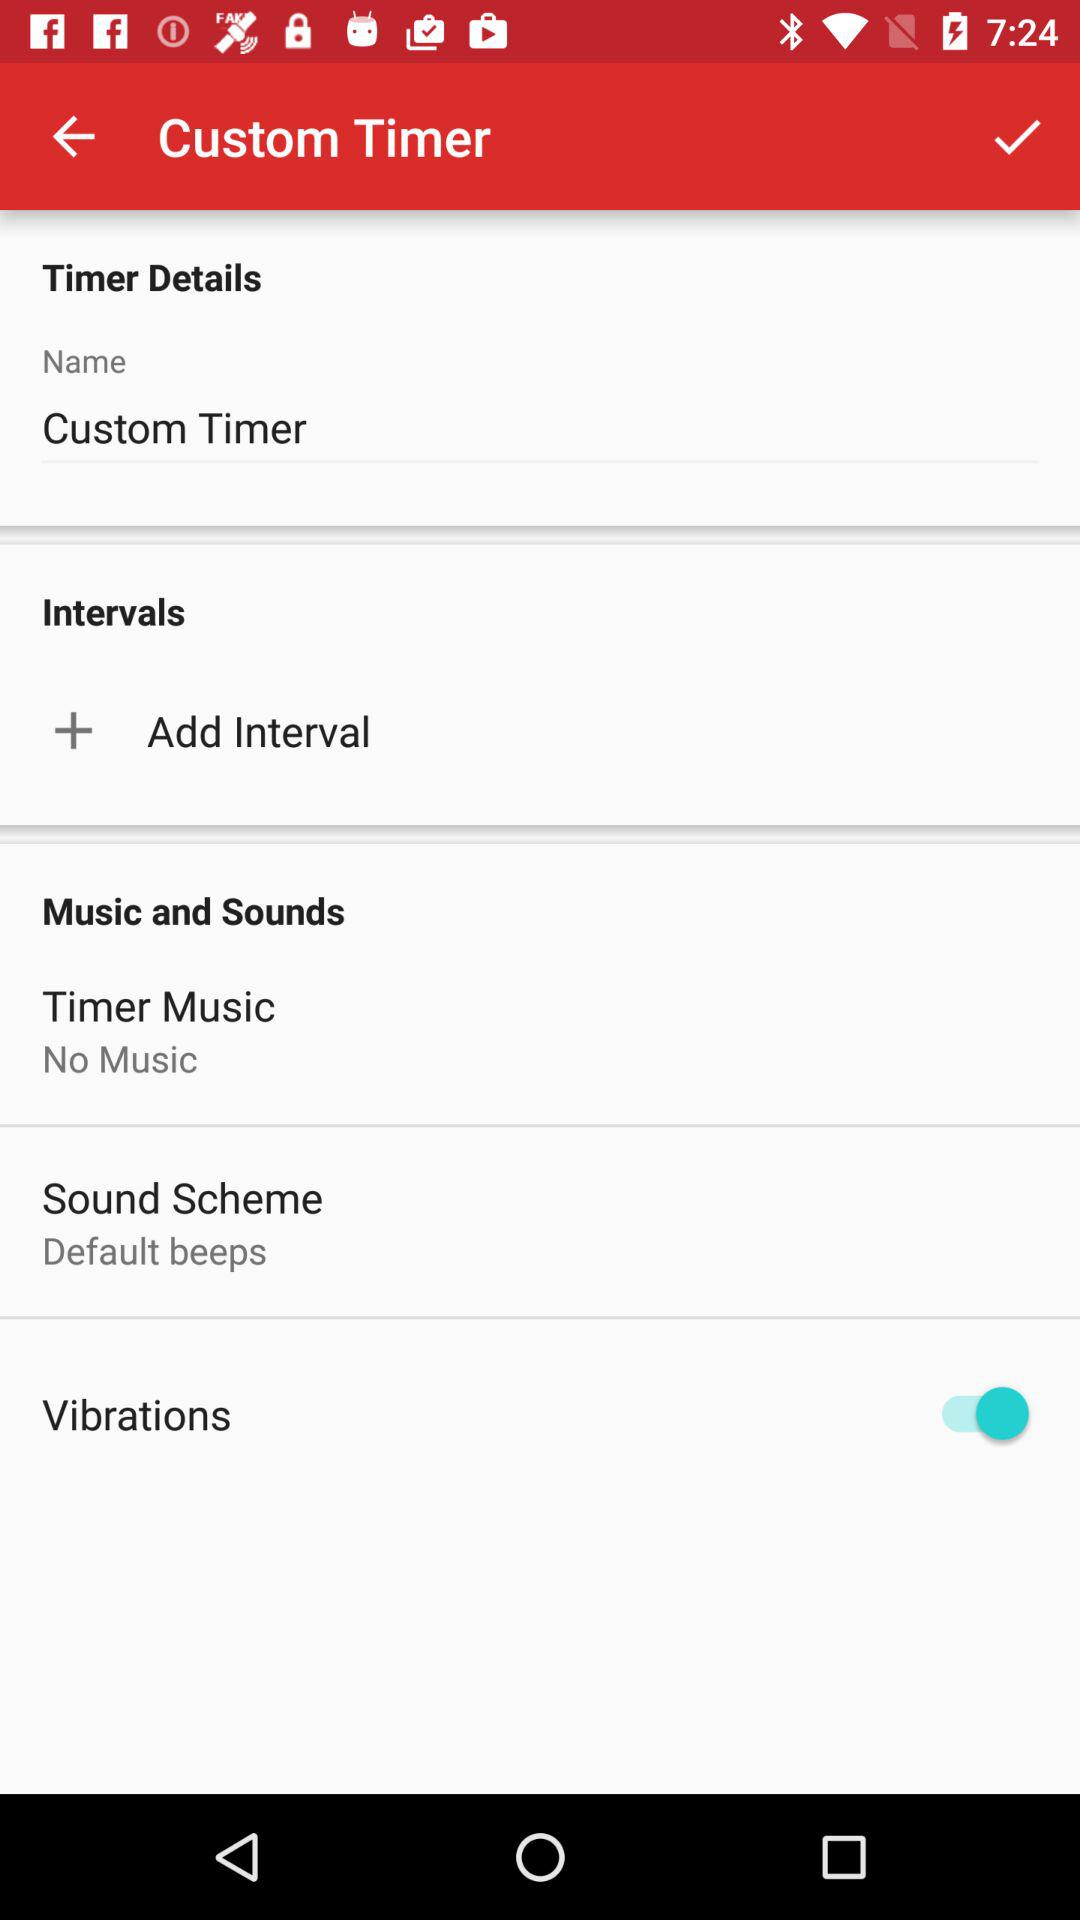What is the name of the timer? The name of the timer is "Custom Timer". 